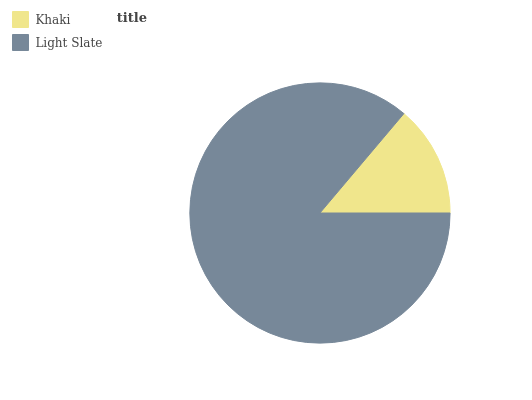Is Khaki the minimum?
Answer yes or no. Yes. Is Light Slate the maximum?
Answer yes or no. Yes. Is Light Slate the minimum?
Answer yes or no. No. Is Light Slate greater than Khaki?
Answer yes or no. Yes. Is Khaki less than Light Slate?
Answer yes or no. Yes. Is Khaki greater than Light Slate?
Answer yes or no. No. Is Light Slate less than Khaki?
Answer yes or no. No. Is Light Slate the high median?
Answer yes or no. Yes. Is Khaki the low median?
Answer yes or no. Yes. Is Khaki the high median?
Answer yes or no. No. Is Light Slate the low median?
Answer yes or no. No. 